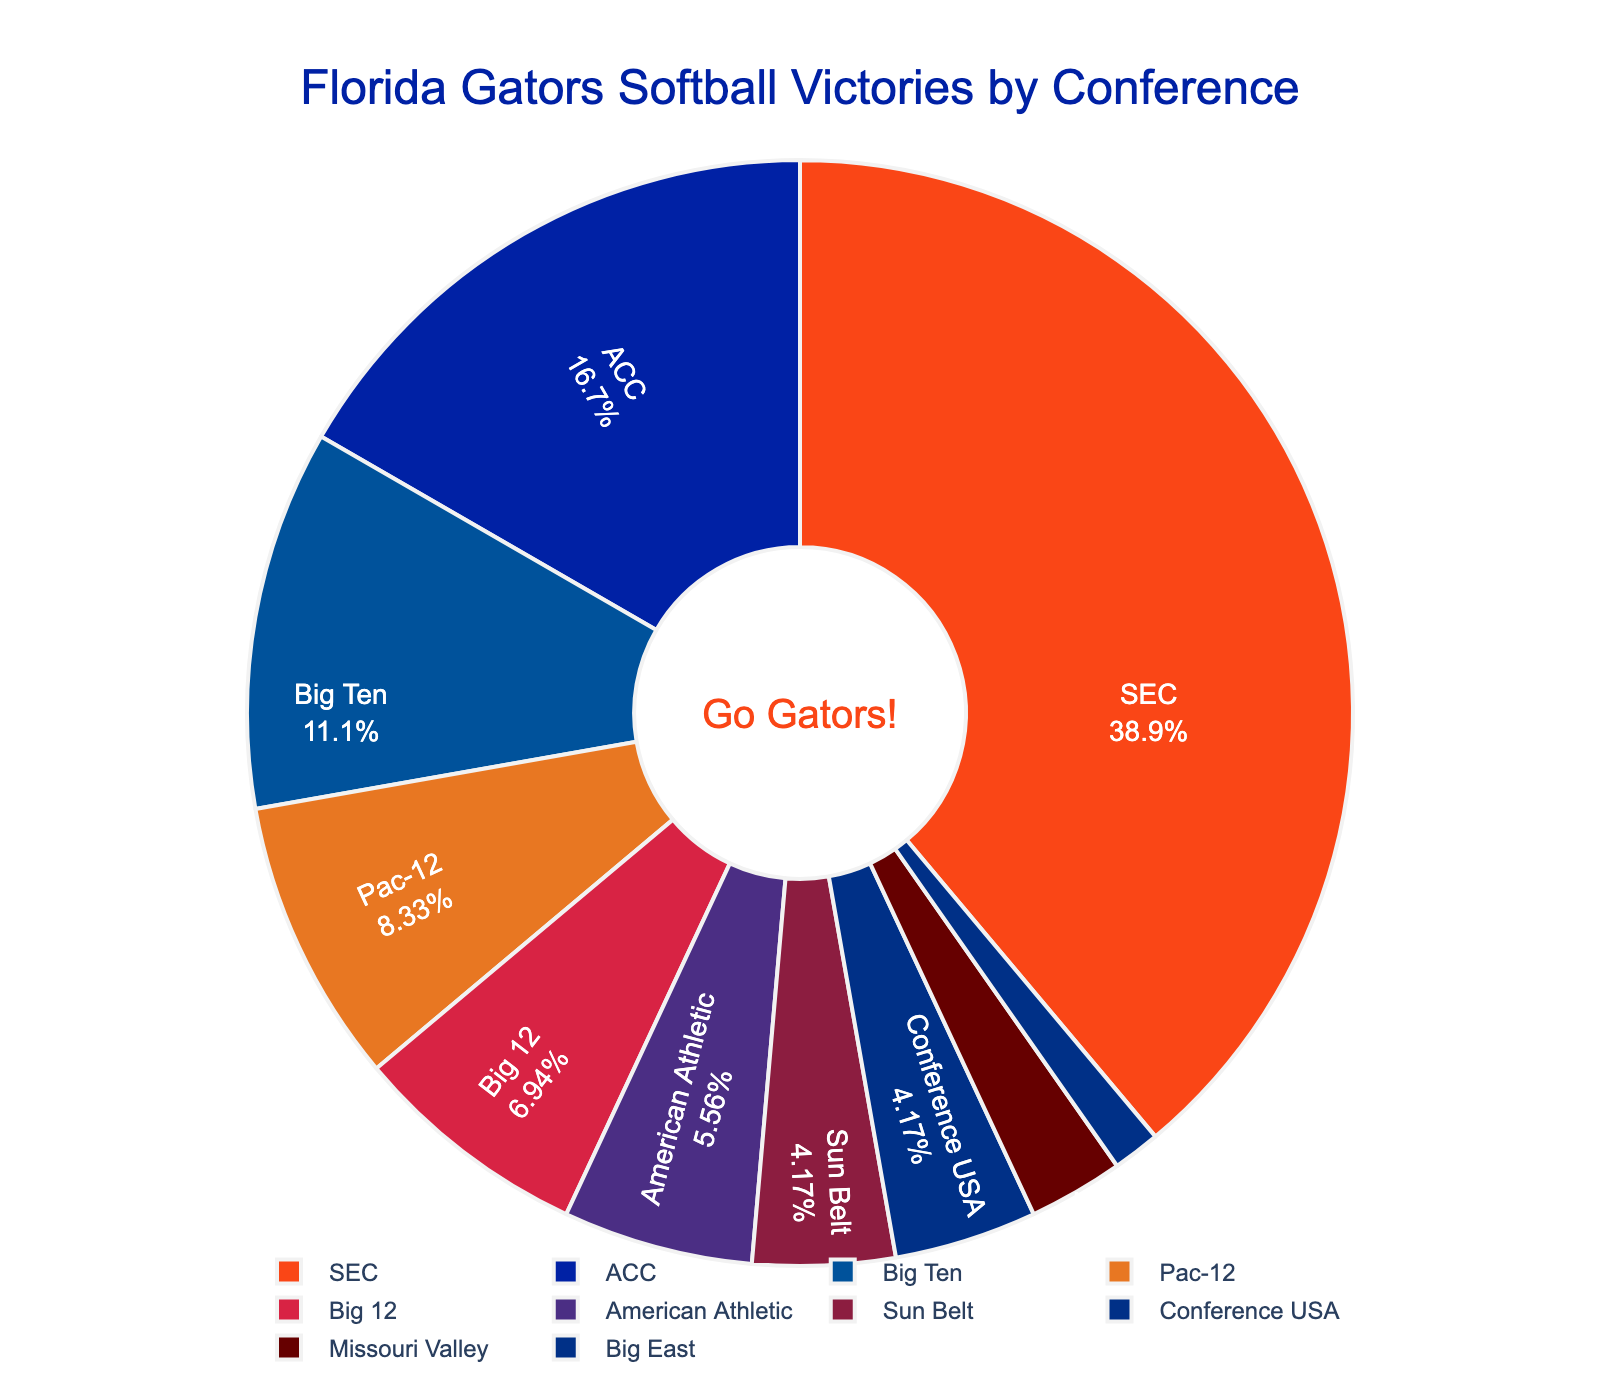Which conference did the Florida Gators softball team have the most victories against? The largest slice in the pie chart corresponds to the SEC conference, which represents the highest number of victories.
Answer: SEC What percentage of the victories were against SEC opponents? The portion of the pie chart labeled SEC shows both the label and percentage of victories.
Answer: 43.8% How many more victories did the Gators have against ACC opponents compared to Big Ten opponents? The slice representing ACC shows 12 victories, and the Big Ten shows 8 victories. Subtracting these, we get 12 - 8 = 4.
Answer: 4 What is the total number of victories against conferences other than the SEC? Adding up the victories in all conferences except SEC: 12 (ACC) + 8 (Big Ten) + 6 (Pac-12) + 5 (Big 12) + 4 (American Athletic) + 3 (Sun Belt) + 3 (Conference USA) + 2 (Missouri Valley) + 1 (Big East) = 44.
Answer: 44 How does the number of victories against the Pac-12 compare to the Big 12? The pie chart shows 6 victories against Pac-12 and 5 victories against Big 12. Pac-12 has 1 more victory.
Answer: Pac-12 has 1 more What percentage of the victories came from teams in the American Athletic and Sun Belt conferences combined? The slice representing American Athletic has 4 victories and Sun Belt has 3 victories. The total is 4 + 3 = 7. The percentage can be calculated from the chart.
Answer: 10.9% What is the total number of victories represented in the chart? Adding up all the values listed: 28 (SEC) + 12 (ACC) + 8 (Big Ten) + 6 (Pac-12) + 5 (Big 12) + 4 (American Athletic) + 3 (Sun Belt) + 3 (Conference USA) + 2 (Missouri Valley) + 1 (Big East) = 72.
Answer: 72 Which conferences have fewer than 4 victories, and how many conferences are there? The pie chart shows victories for conferences: Pac-12 (6), Big 12 (5), American Athletic (4), Sun Belt (3), Conference USA (3), Missouri Valley (2), and Big East (1). Count the conferences with fewer than 4 victories.
Answer: 5 conferences What fraction of the total victories are against Big Ten opponents? The pie chart shows 8 victories against Big Ten, out of a total of 72 victories. The fraction is 8/72, which simplifies to 1/9.
Answer: 1/9 